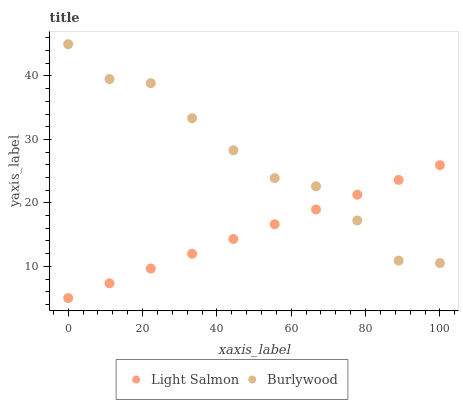Does Light Salmon have the minimum area under the curve?
Answer yes or no. Yes. Does Burlywood have the maximum area under the curve?
Answer yes or no. Yes. Does Light Salmon have the maximum area under the curve?
Answer yes or no. No. Is Light Salmon the smoothest?
Answer yes or no. Yes. Is Burlywood the roughest?
Answer yes or no. Yes. Is Light Salmon the roughest?
Answer yes or no. No. Does Light Salmon have the lowest value?
Answer yes or no. Yes. Does Burlywood have the highest value?
Answer yes or no. Yes. Does Light Salmon have the highest value?
Answer yes or no. No. Does Burlywood intersect Light Salmon?
Answer yes or no. Yes. Is Burlywood less than Light Salmon?
Answer yes or no. No. Is Burlywood greater than Light Salmon?
Answer yes or no. No. 